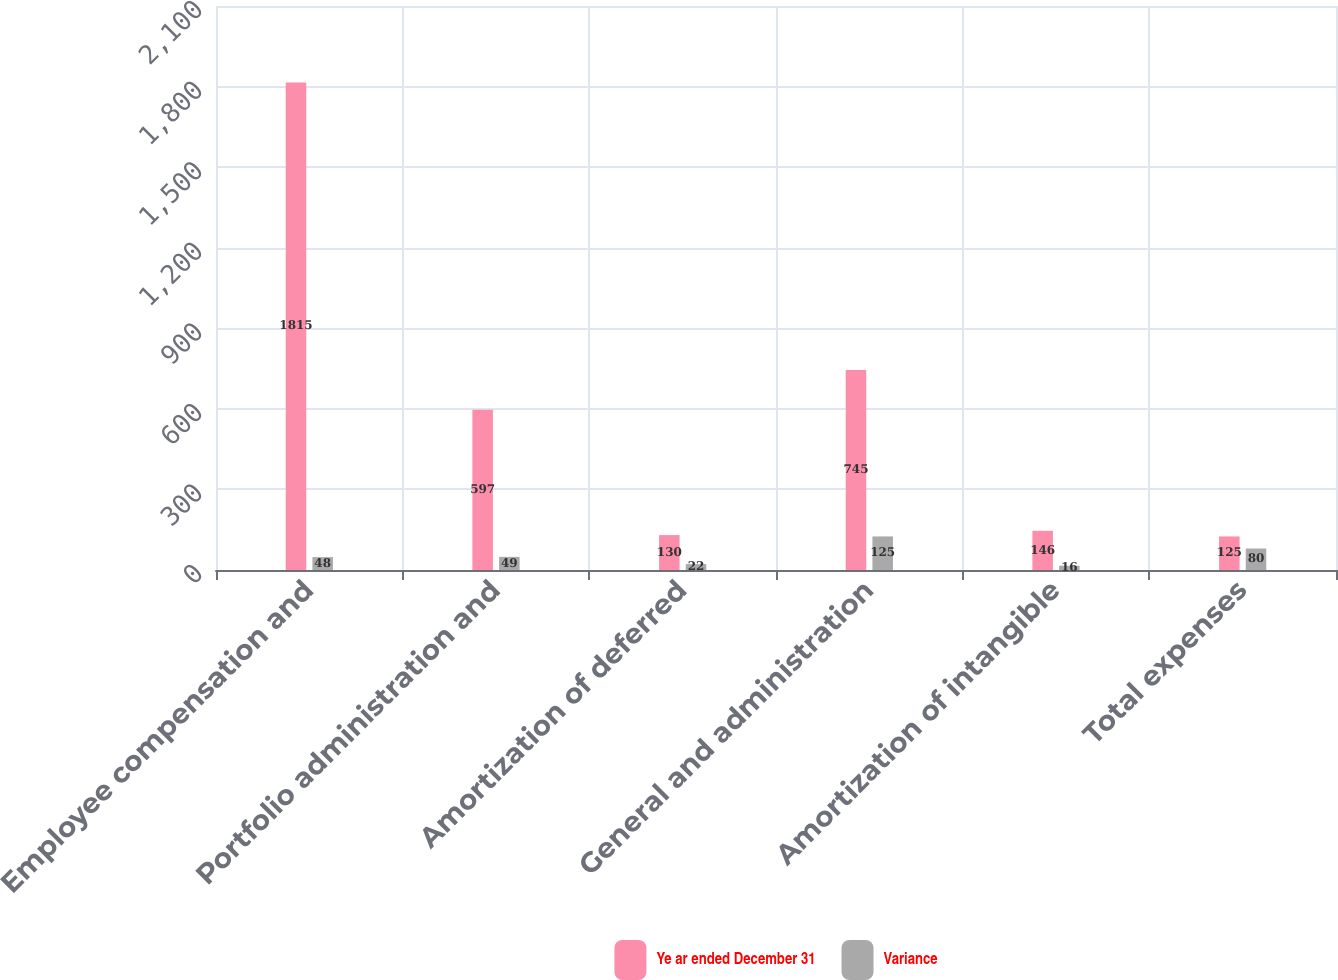Convert chart. <chart><loc_0><loc_0><loc_500><loc_500><stacked_bar_chart><ecel><fcel>Employee compensation and<fcel>Portfolio administration and<fcel>Amortization of deferred<fcel>General and administration<fcel>Amortization of intangible<fcel>Total expenses<nl><fcel>Ye ar ended December 31<fcel>1815<fcel>597<fcel>130<fcel>745<fcel>146<fcel>125<nl><fcel>Variance<fcel>48<fcel>49<fcel>22<fcel>125<fcel>16<fcel>80<nl></chart> 